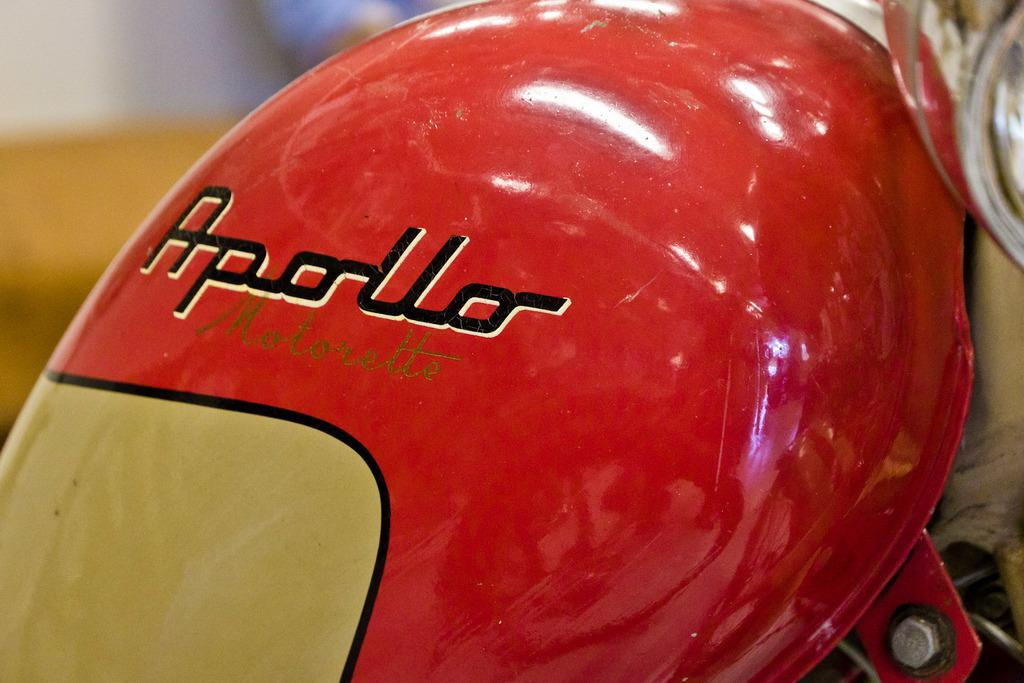What object is the main focus of the image? There is a petrol tank in the image. To which vehicle does the petrol tank belong? The petrol tank belongs to a motorbike. Can you describe the background of the image? The background of the image is blurry. What month is it in the image? The month is not mentioned or depicted in the image. Can you tell me how many heads are visible in the image? There are no heads visible in the image; it primarily features a petrol tank and a blurry background. 